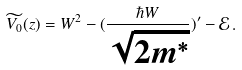<formula> <loc_0><loc_0><loc_500><loc_500>\widetilde { V _ { 0 } } ( z ) = W ^ { 2 } - ( \frac { \hbar { W } } { \sqrt { 2 m ^ { * } } } ) ^ { \prime } - \mathcal { E } \, .</formula> 